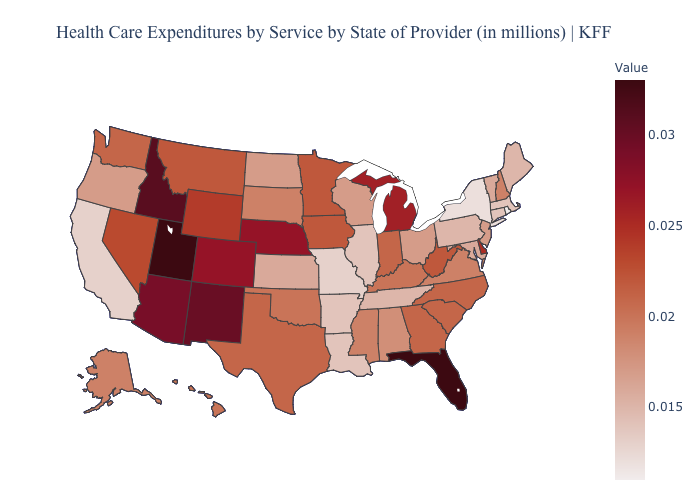Which states have the lowest value in the MidWest?
Answer briefly. Missouri. Which states have the highest value in the USA?
Quick response, please. Florida, Utah. Does Utah have the highest value in the USA?
Quick response, please. Yes. Which states have the highest value in the USA?
Quick response, please. Florida, Utah. Does South Carolina have the highest value in the South?
Give a very brief answer. No. Which states have the highest value in the USA?
Be succinct. Florida, Utah. 